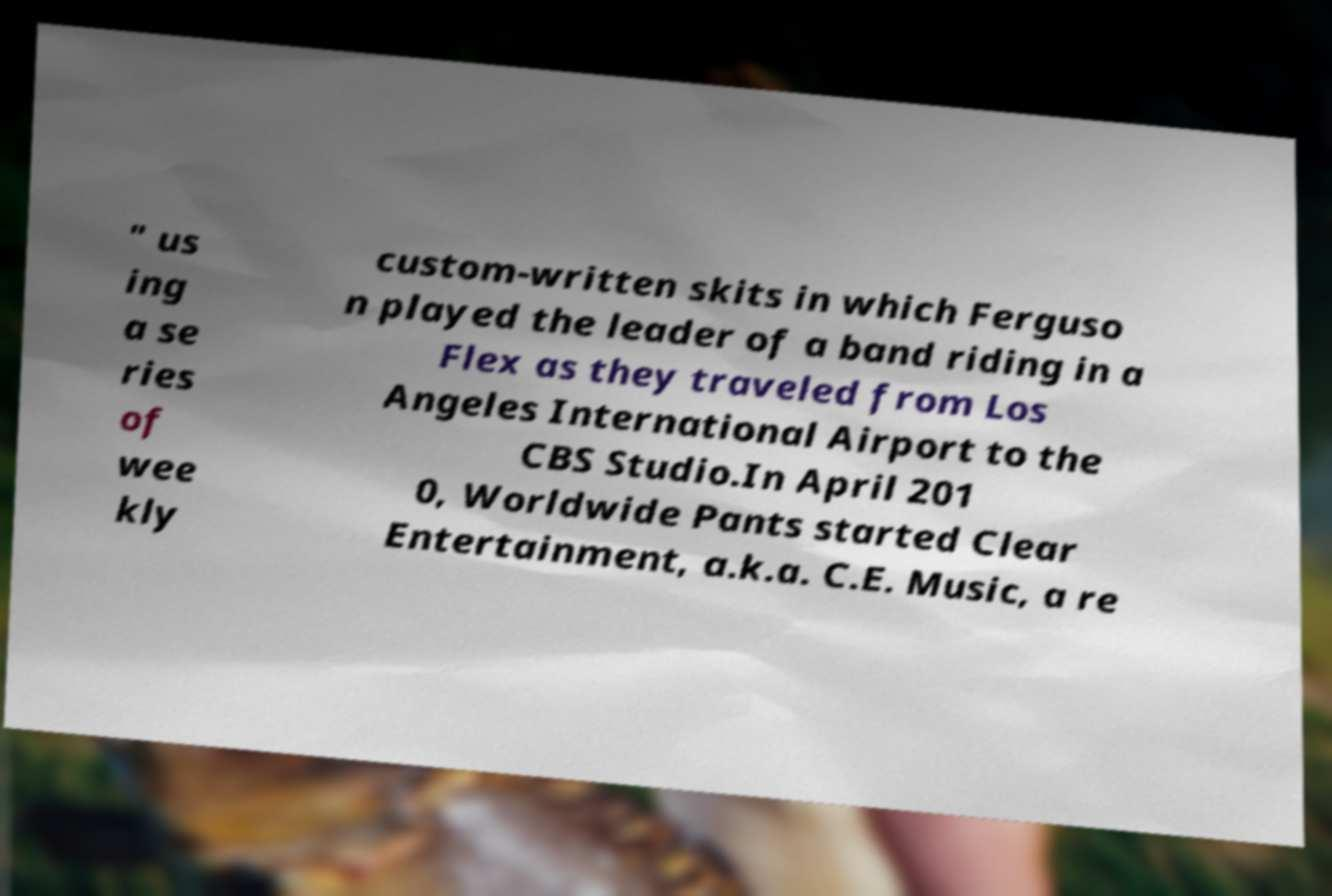There's text embedded in this image that I need extracted. Can you transcribe it verbatim? " us ing a se ries of wee kly custom-written skits in which Ferguso n played the leader of a band riding in a Flex as they traveled from Los Angeles International Airport to the CBS Studio.In April 201 0, Worldwide Pants started Clear Entertainment, a.k.a. C.E. Music, a re 